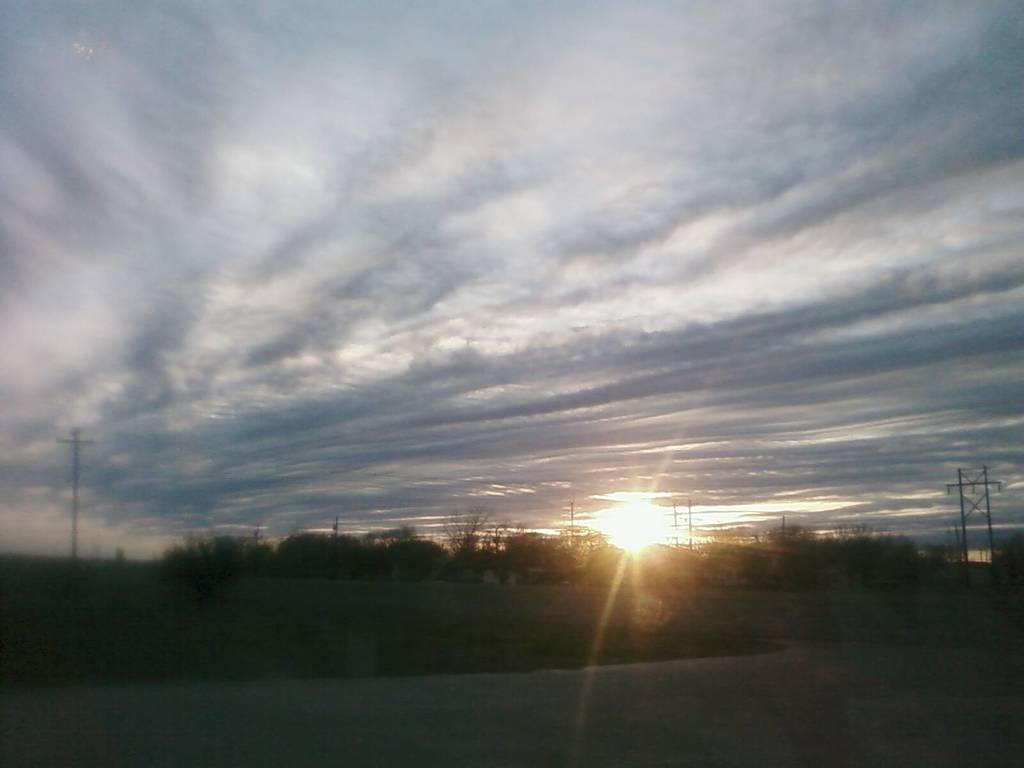Can you describe this image briefly? It is the image of a sunrise, the bright sunshine is falling on the surface and there are plenty of trees and the sun is rising from behind the trees. 